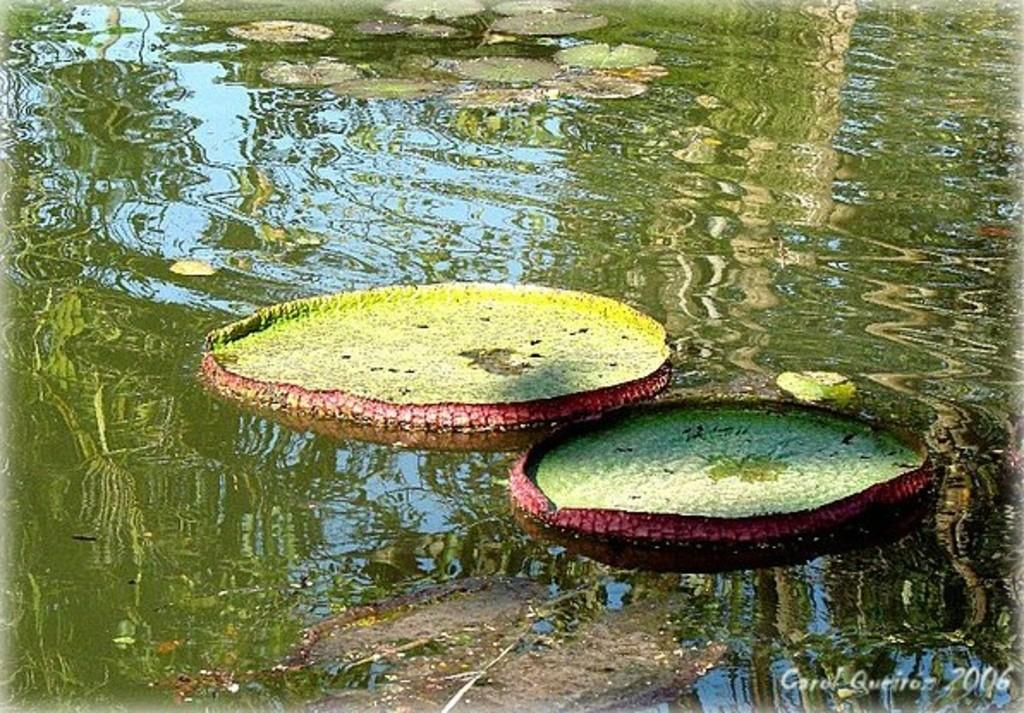What is the main feature of the image? There is a water body in the image. What can be seen floating on the water in the image? There are lotus leaves on the water in the image. What word is written on the lotus leaves in the image? There are no words written on the lotus leaves in the image. How many stars can be seen in the water in the image? There are no stars visible in the image; it features a water body with lotus leaves. 